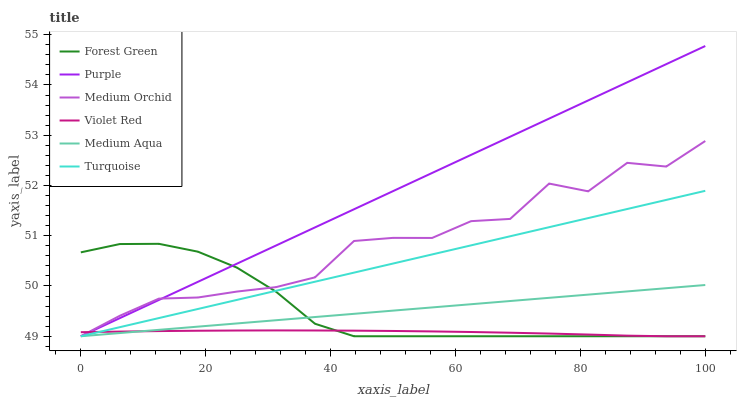Does Violet Red have the minimum area under the curve?
Answer yes or no. Yes. Does Purple have the maximum area under the curve?
Answer yes or no. Yes. Does Medium Orchid have the minimum area under the curve?
Answer yes or no. No. Does Medium Orchid have the maximum area under the curve?
Answer yes or no. No. Is Purple the smoothest?
Answer yes or no. Yes. Is Medium Orchid the roughest?
Answer yes or no. Yes. Is Medium Orchid the smoothest?
Answer yes or no. No. Is Purple the roughest?
Answer yes or no. No. Does Violet Red have the lowest value?
Answer yes or no. Yes. Does Purple have the highest value?
Answer yes or no. Yes. Does Medium Orchid have the highest value?
Answer yes or no. No. Does Medium Aqua intersect Purple?
Answer yes or no. Yes. Is Medium Aqua less than Purple?
Answer yes or no. No. Is Medium Aqua greater than Purple?
Answer yes or no. No. 